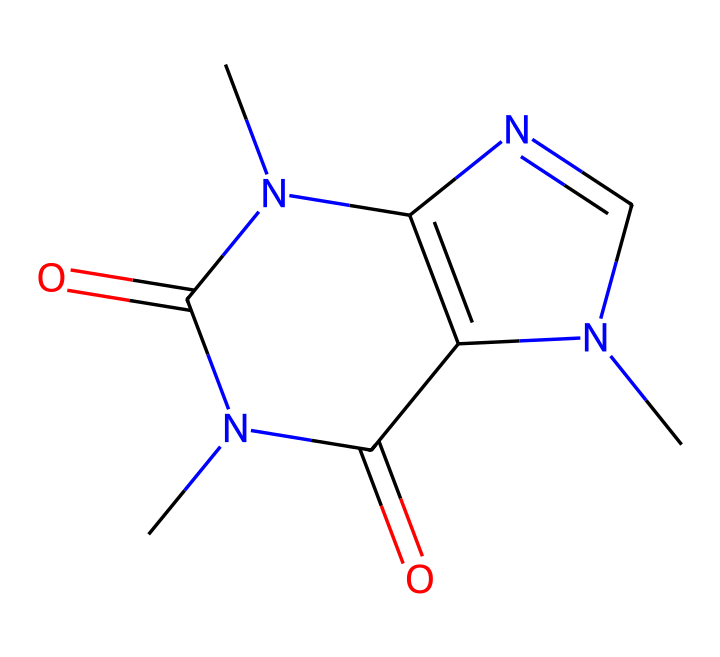What is the molecular formula of caffeine? To find the molecular formula, we count the number of each type of atom in the structure. The SMILES indicates there are 8 carbon atoms (C), 10 hydrogen atoms (H), 4 nitrogen atoms (N), and 2 oxygen atoms (O). Thus, the molecular formula is C8H10N4O2.
Answer: C8H10N4O2 How many rings are present in the structure of caffeine? Analyzing the chemical structure, we identify two fused rings. The presence of both nitrogen and carbon in the rings is indicative of a bicyclic structure. Therefore, there are 2 rings in caffeine.
Answer: 2 What type of isomerism can caffeine exhibit? Caffeine can exhibit geometric isomerism due to the presence of double bonds and the ability of certain substituents to arrange differently around these bonds. This results in different spatial arrangements of the same molecular formula.
Answer: geometric How many nitrogen atoms are in caffeine? The structure shows there are four nitrogen atoms present, identifiable from the pentagonal and hexagonal rings formed in caffeine's structure.
Answer: 4 What does the presence of nitrogen atoms in caffeine suggest about its properties? The presence of nitrogen atoms indicates that caffeine is a nitrogen-containing compound, specifically an alkaloid, which is often associated with pharmacological effects, such as stimulant properties that can enhance alertness.
Answer: stimulant Are there any chiral centers in caffeine? A chiral center is defined as a carbon atom bound to four different substituents. In caffeine's structure, after examining, there are no such carbon atoms present, indicating that caffeine does not have chiral centers.
Answer: no 